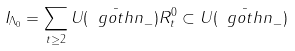<formula> <loc_0><loc_0><loc_500><loc_500>I _ { \Lambda _ { 0 } } = \sum _ { t \geq 2 } U ( \bar { \ g o t h { n } } _ { - } ) R _ { t } ^ { 0 } \subset U ( \bar { \ g o t h { n } } _ { - } )</formula> 